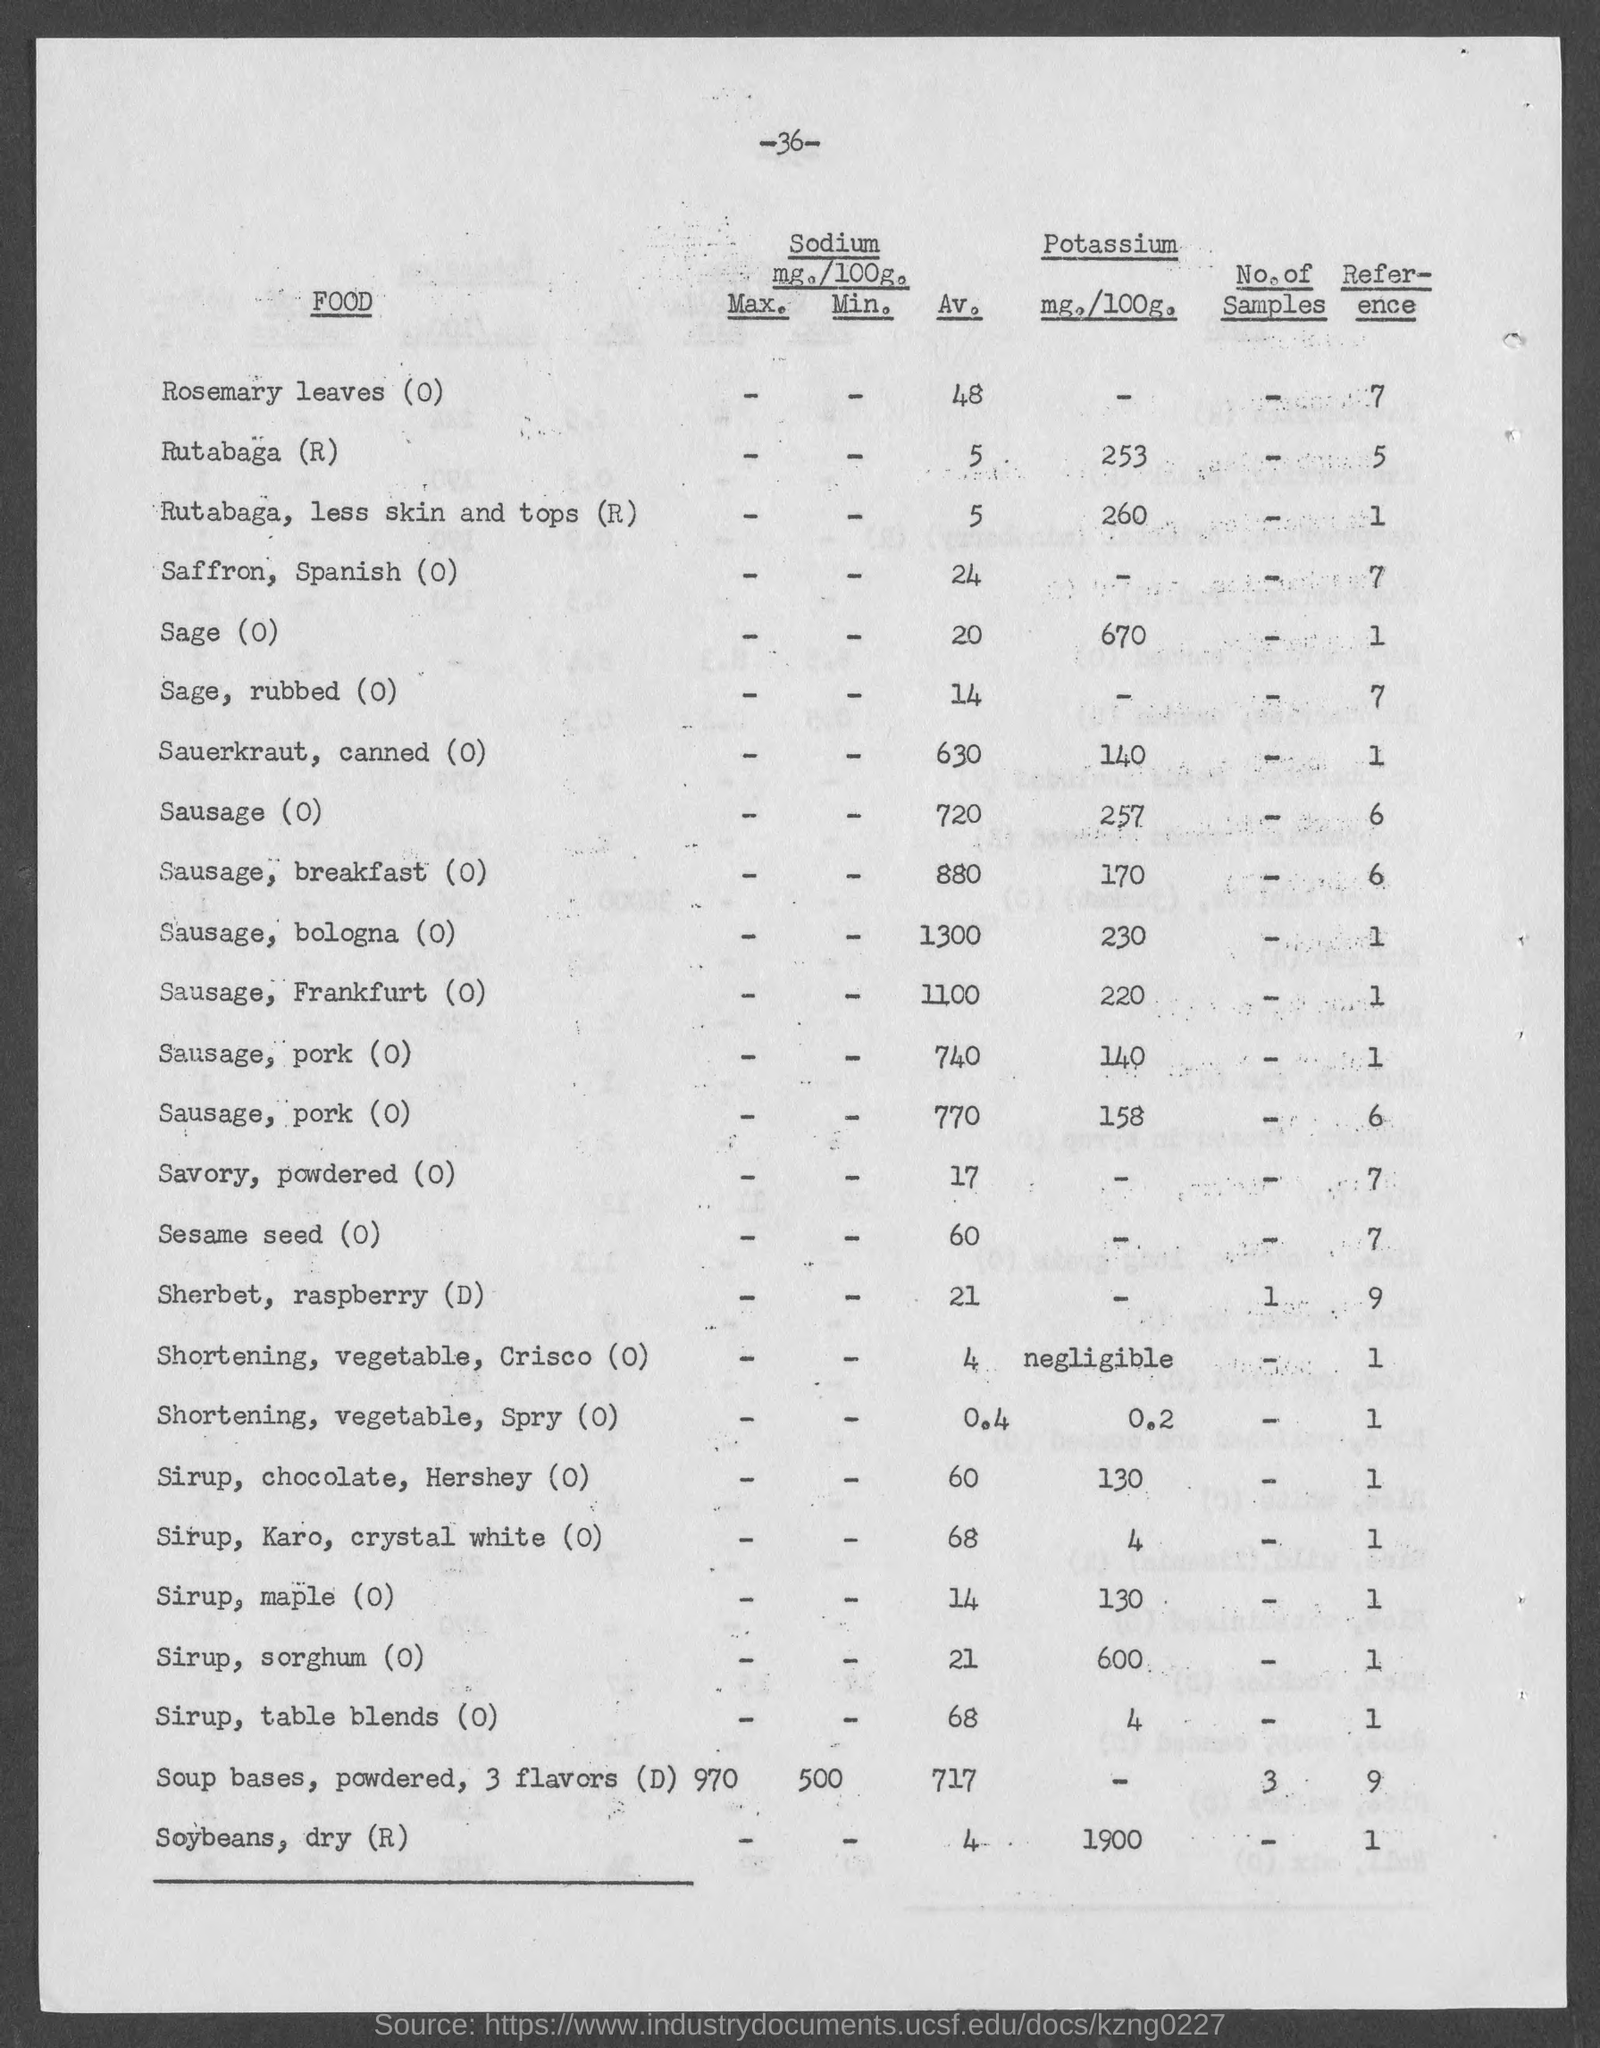What is the number at top of the page ?
Your answer should be compact. 36. What is the reference no. for rosemary leaves (o)?
Your answer should be very brief. 7. What is the reference no. for rutabaga (r) ?
Ensure brevity in your answer.  5. What is the reference no. for rutabaga, less skin and tops (r) ?
Your answer should be compact. 1. What is the reference no. for saffron, spanish (o)?
Your response must be concise. 7. What is the reference no. for sage(o)?
Make the answer very short. 1. What is the reference no. for sage, rubbed (o)?
Provide a succinct answer. 7. What is the reference no. for sauerkraut, canned (o)?
Offer a terse response. 1. What is the reference no. for sausage (o)?
Make the answer very short. 6. What is the reference no. for sausage, breakfast (o)?
Give a very brief answer. 6. 